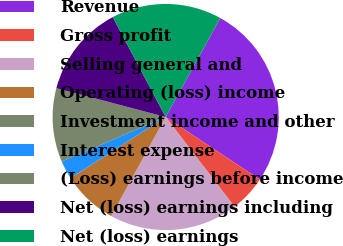Convert chart to OTSL. <chart><loc_0><loc_0><loc_500><loc_500><pie_chart><fcel>Revenue<fcel>Gross profit<fcel>Selling general and<fcel>Operating (loss) income<fcel>Investment income and other<fcel>Interest expense<fcel>(Loss) earnings before income<fcel>Net (loss) earnings including<fcel>Net (loss) earnings<nl><fcel>26.29%<fcel>5.27%<fcel>18.41%<fcel>7.9%<fcel>0.02%<fcel>2.65%<fcel>10.53%<fcel>13.15%<fcel>15.78%<nl></chart> 